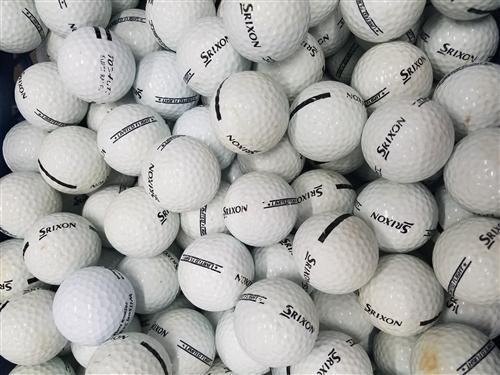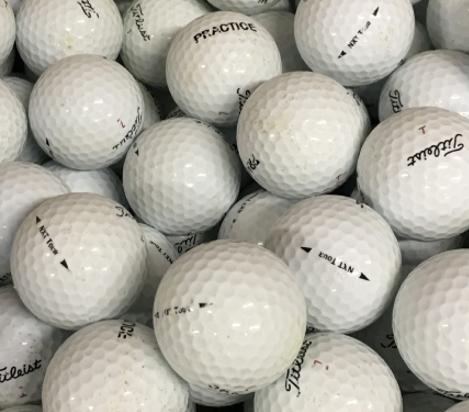The first image is the image on the left, the second image is the image on the right. Assess this claim about the two images: "All the balls in the image on the right are white.". Correct or not? Answer yes or no. Yes. The first image is the image on the left, the second image is the image on the right. Given the left and right images, does the statement "An image shows yellow and orange balls among white golf balls." hold true? Answer yes or no. No. 